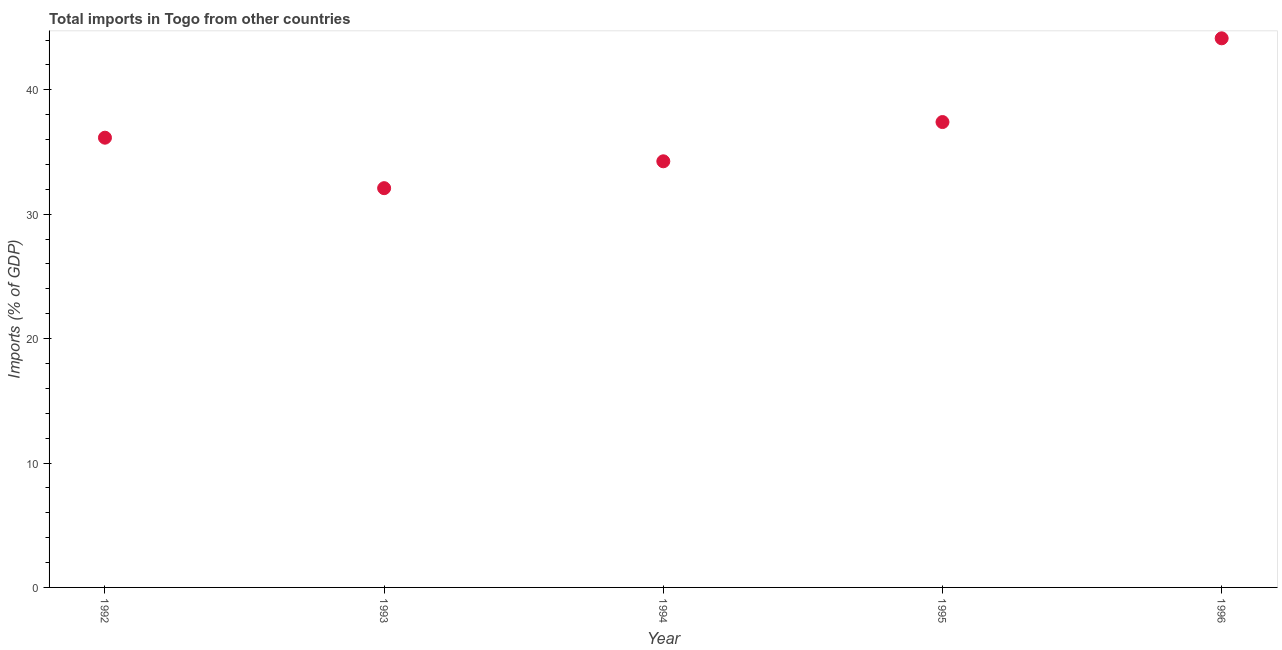What is the total imports in 1995?
Your answer should be very brief. 37.41. Across all years, what is the maximum total imports?
Your answer should be very brief. 44.14. Across all years, what is the minimum total imports?
Your response must be concise. 32.09. What is the sum of the total imports?
Make the answer very short. 184.05. What is the difference between the total imports in 1992 and 1993?
Ensure brevity in your answer.  4.06. What is the average total imports per year?
Keep it short and to the point. 36.81. What is the median total imports?
Give a very brief answer. 36.15. In how many years, is the total imports greater than 2 %?
Give a very brief answer. 5. Do a majority of the years between 1993 and 1994 (inclusive) have total imports greater than 14 %?
Provide a succinct answer. Yes. What is the ratio of the total imports in 1992 to that in 1995?
Keep it short and to the point. 0.97. Is the difference between the total imports in 1993 and 1996 greater than the difference between any two years?
Offer a terse response. Yes. What is the difference between the highest and the second highest total imports?
Offer a terse response. 6.73. Is the sum of the total imports in 1992 and 1994 greater than the maximum total imports across all years?
Offer a very short reply. Yes. What is the difference between the highest and the lowest total imports?
Your answer should be very brief. 12.05. In how many years, is the total imports greater than the average total imports taken over all years?
Keep it short and to the point. 2. Does the total imports monotonically increase over the years?
Provide a succinct answer. No. How many years are there in the graph?
Provide a succinct answer. 5. What is the difference between two consecutive major ticks on the Y-axis?
Offer a very short reply. 10. Are the values on the major ticks of Y-axis written in scientific E-notation?
Your answer should be compact. No. What is the title of the graph?
Your response must be concise. Total imports in Togo from other countries. What is the label or title of the X-axis?
Ensure brevity in your answer.  Year. What is the label or title of the Y-axis?
Offer a terse response. Imports (% of GDP). What is the Imports (% of GDP) in 1992?
Provide a succinct answer. 36.15. What is the Imports (% of GDP) in 1993?
Make the answer very short. 32.09. What is the Imports (% of GDP) in 1994?
Your response must be concise. 34.25. What is the Imports (% of GDP) in 1995?
Your response must be concise. 37.41. What is the Imports (% of GDP) in 1996?
Keep it short and to the point. 44.14. What is the difference between the Imports (% of GDP) in 1992 and 1993?
Offer a terse response. 4.06. What is the difference between the Imports (% of GDP) in 1992 and 1994?
Your answer should be very brief. 1.9. What is the difference between the Imports (% of GDP) in 1992 and 1995?
Offer a very short reply. -1.26. What is the difference between the Imports (% of GDP) in 1992 and 1996?
Provide a short and direct response. -7.99. What is the difference between the Imports (% of GDP) in 1993 and 1994?
Keep it short and to the point. -2.16. What is the difference between the Imports (% of GDP) in 1993 and 1995?
Your answer should be compact. -5.31. What is the difference between the Imports (% of GDP) in 1993 and 1996?
Offer a very short reply. -12.05. What is the difference between the Imports (% of GDP) in 1994 and 1995?
Give a very brief answer. -3.16. What is the difference between the Imports (% of GDP) in 1994 and 1996?
Your answer should be compact. -9.89. What is the difference between the Imports (% of GDP) in 1995 and 1996?
Your answer should be compact. -6.73. What is the ratio of the Imports (% of GDP) in 1992 to that in 1993?
Offer a very short reply. 1.13. What is the ratio of the Imports (% of GDP) in 1992 to that in 1994?
Ensure brevity in your answer.  1.05. What is the ratio of the Imports (% of GDP) in 1992 to that in 1995?
Your answer should be compact. 0.97. What is the ratio of the Imports (% of GDP) in 1992 to that in 1996?
Your answer should be very brief. 0.82. What is the ratio of the Imports (% of GDP) in 1993 to that in 1994?
Provide a short and direct response. 0.94. What is the ratio of the Imports (% of GDP) in 1993 to that in 1995?
Offer a very short reply. 0.86. What is the ratio of the Imports (% of GDP) in 1993 to that in 1996?
Offer a very short reply. 0.73. What is the ratio of the Imports (% of GDP) in 1994 to that in 1995?
Give a very brief answer. 0.92. What is the ratio of the Imports (% of GDP) in 1994 to that in 1996?
Your answer should be very brief. 0.78. What is the ratio of the Imports (% of GDP) in 1995 to that in 1996?
Your answer should be very brief. 0.85. 